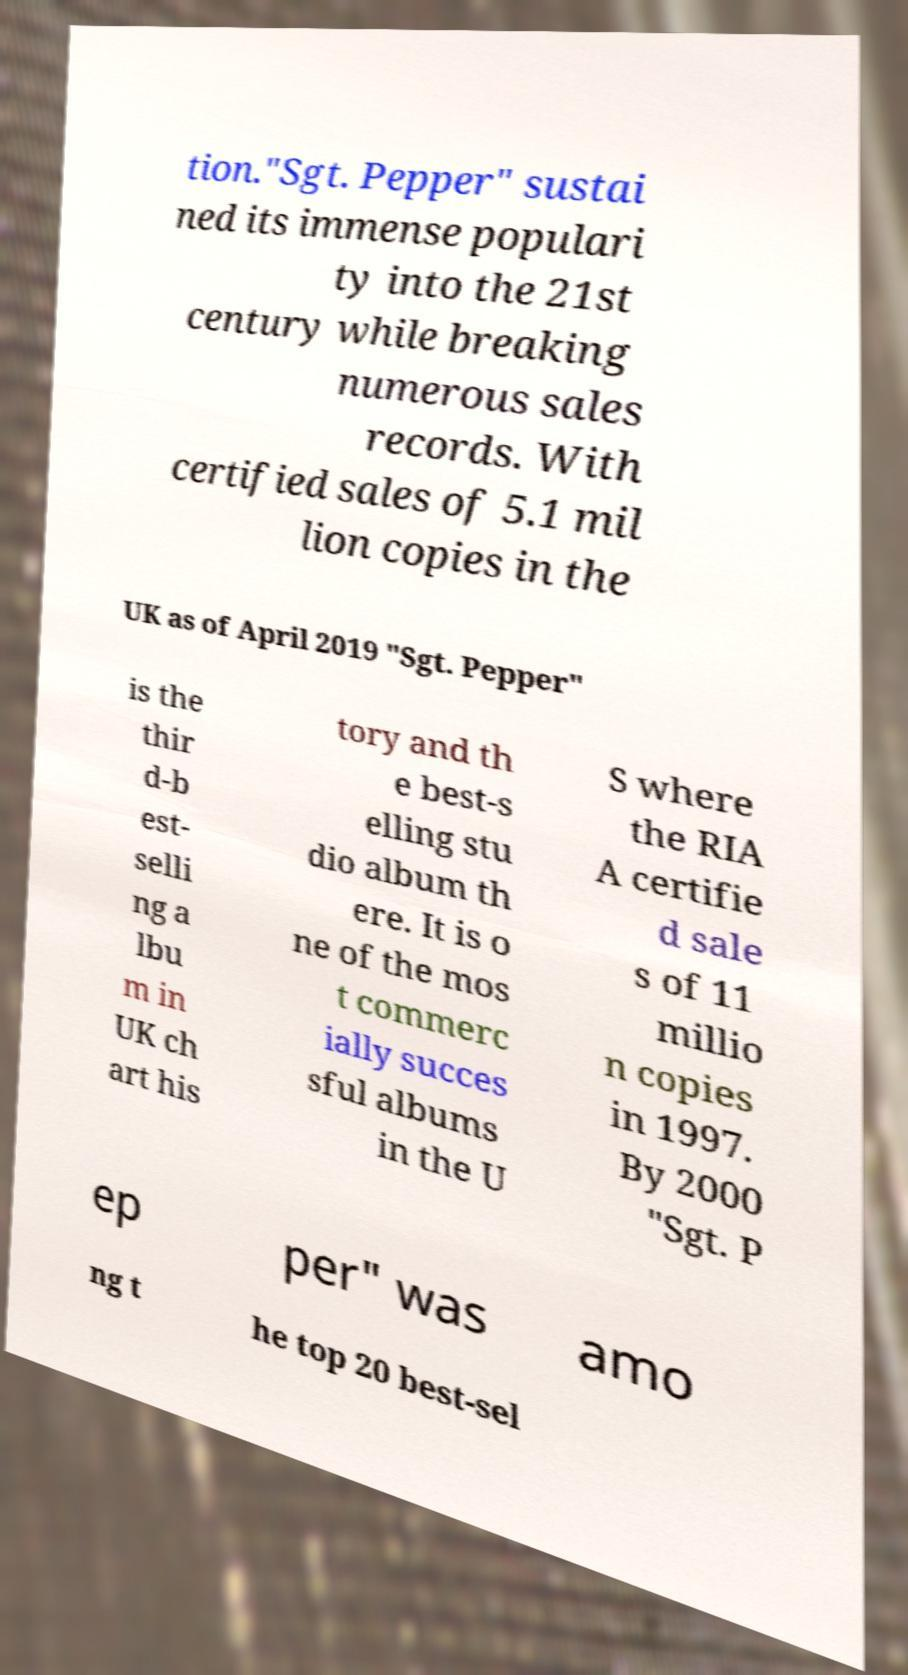What messages or text are displayed in this image? I need them in a readable, typed format. tion."Sgt. Pepper" sustai ned its immense populari ty into the 21st century while breaking numerous sales records. With certified sales of 5.1 mil lion copies in the UK as of April 2019 "Sgt. Pepper" is the thir d-b est- selli ng a lbu m in UK ch art his tory and th e best-s elling stu dio album th ere. It is o ne of the mos t commerc ially succes sful albums in the U S where the RIA A certifie d sale s of 11 millio n copies in 1997. By 2000 "Sgt. P ep per" was amo ng t he top 20 best-sel 